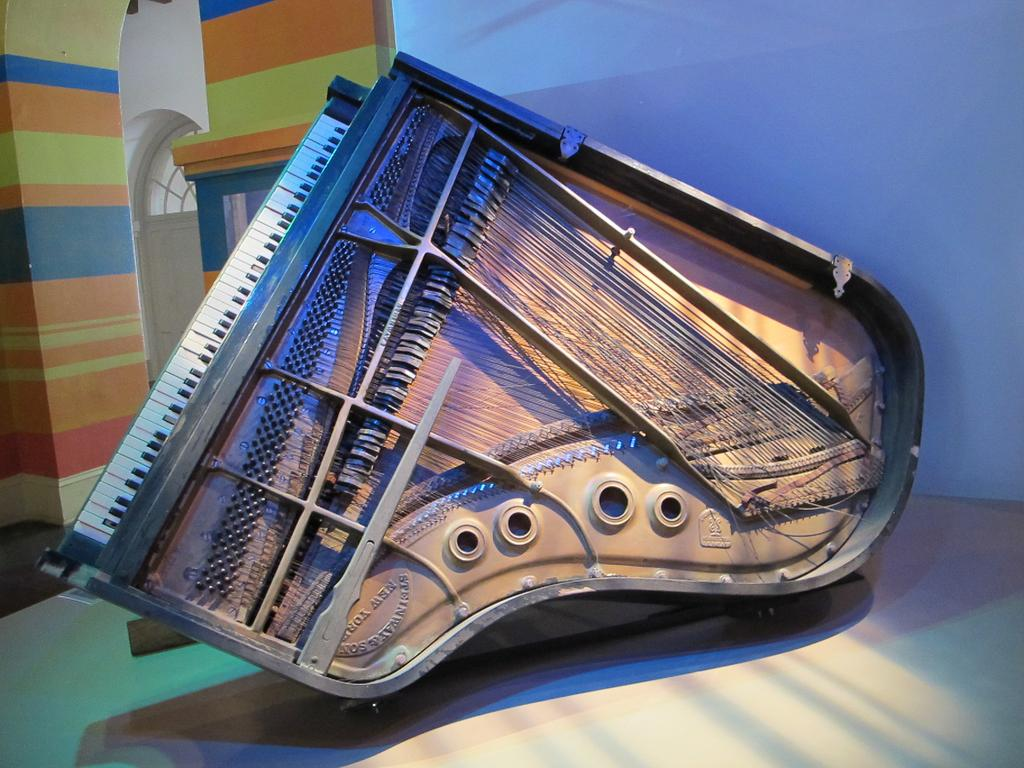What is the main object in the image? There is a piano in the image. Are there any unique features on the piano? Yes, the piano has some painting on it. How is the piano positioned in the image? The piano is placed on a table. What can be observed about the background wall in the image? The background wall has a different color. How many trucks are parked next to the piano in the image? There are no trucks present in the image; it only features a piano on a table with a different colored background wall. Is there a book placed on top of the piano in the image? There is no book visible on the piano in the image. 